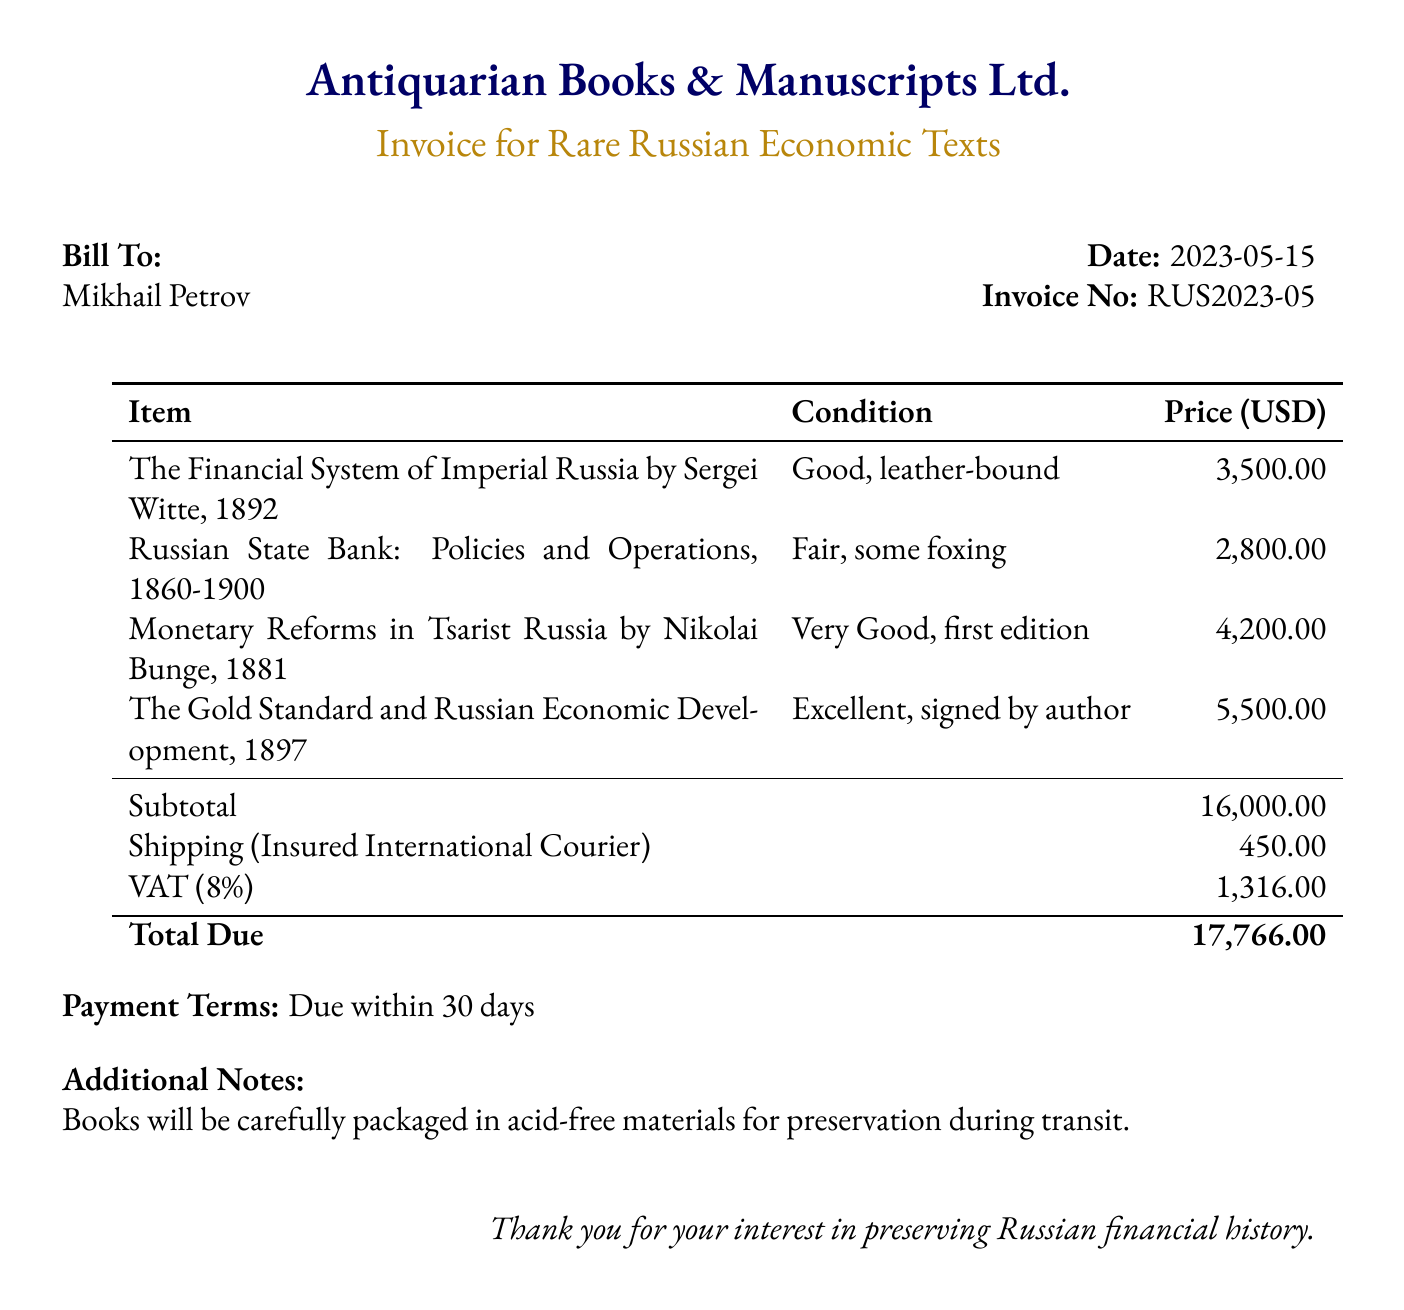What is the name of the first book listed? The first book listed is "The Financial System of Imperial Russia by Sergei Witte".
Answer: The Financial System of Imperial Russia by Sergei Witte What is the price of the book "Monetary Reforms in Tsarist Russia"? The price is explicitly stated in the document as $4,200.00.
Answer: 4,200.00 What is the condition of the book "Russian State Bank: Policies and Operations"? The condition is described as "Fair, some foxing".
Answer: Fair, some foxing What is the subtotal before other charges? The subtotal is calculated as the sum of the prices of the books listed in the document.
Answer: 16,000.00 What is the total due amount? The total due includes all charges, which is indicated as $17,766.00 in the document.
Answer: 17,766.00 What is the shipping cost mentioned in the bill? The document specifies the shipping cost as $450.00.
Answer: 450.00 What is the VAT percentage applied in the invoice? The VAT percentage stated in the invoice is 8%.
Answer: 8% How many days is the payment term given in the bill? The payment term specified is "Due within 30 days".
Answer: 30 days Who is the bill addressed to? The bill is addressed to an individual named Mikhail Petrov.
Answer: Mikhail Petrov 